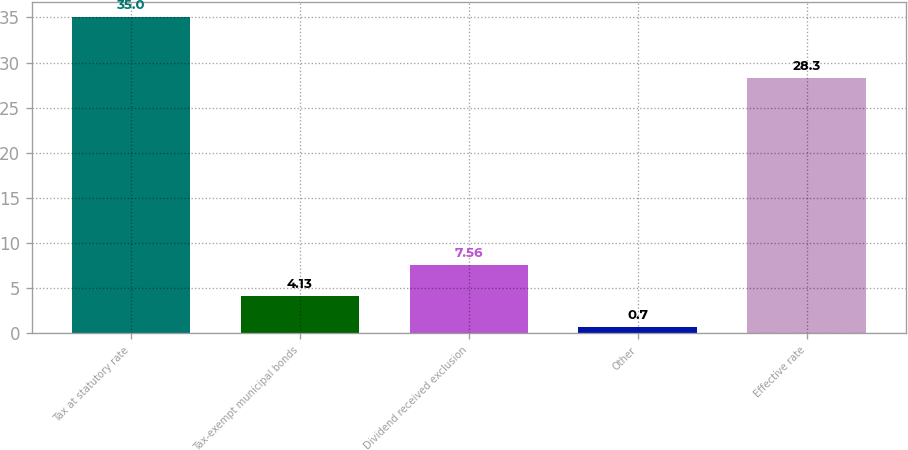Convert chart to OTSL. <chart><loc_0><loc_0><loc_500><loc_500><bar_chart><fcel>Tax at statutory rate<fcel>Tax-exempt municipal bonds<fcel>Dividend received exclusion<fcel>Other<fcel>Effective rate<nl><fcel>35<fcel>4.13<fcel>7.56<fcel>0.7<fcel>28.3<nl></chart> 